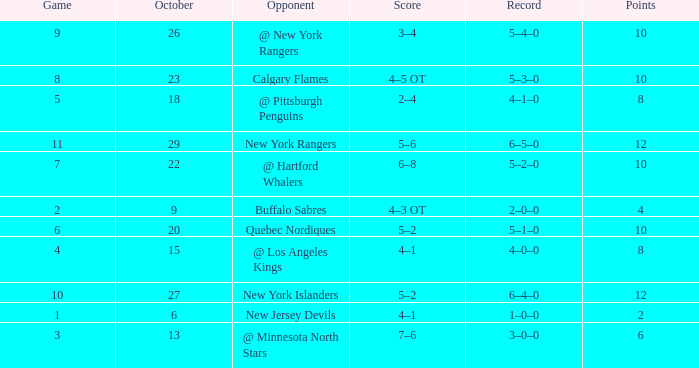Which October has a Record of 5–1–0, and a Game larger than 6? None. 